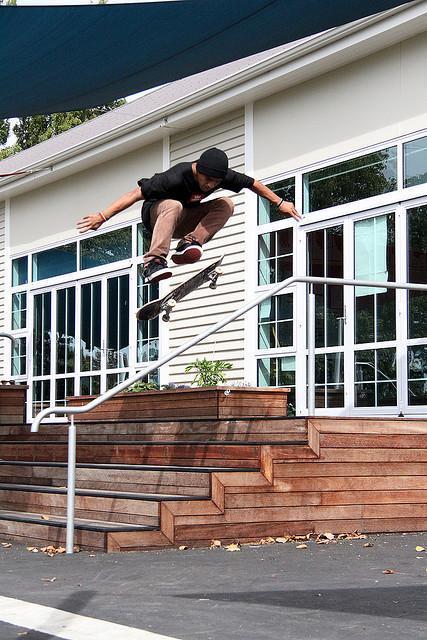How many water bottles are on the ground?
Give a very brief answer. 0. 